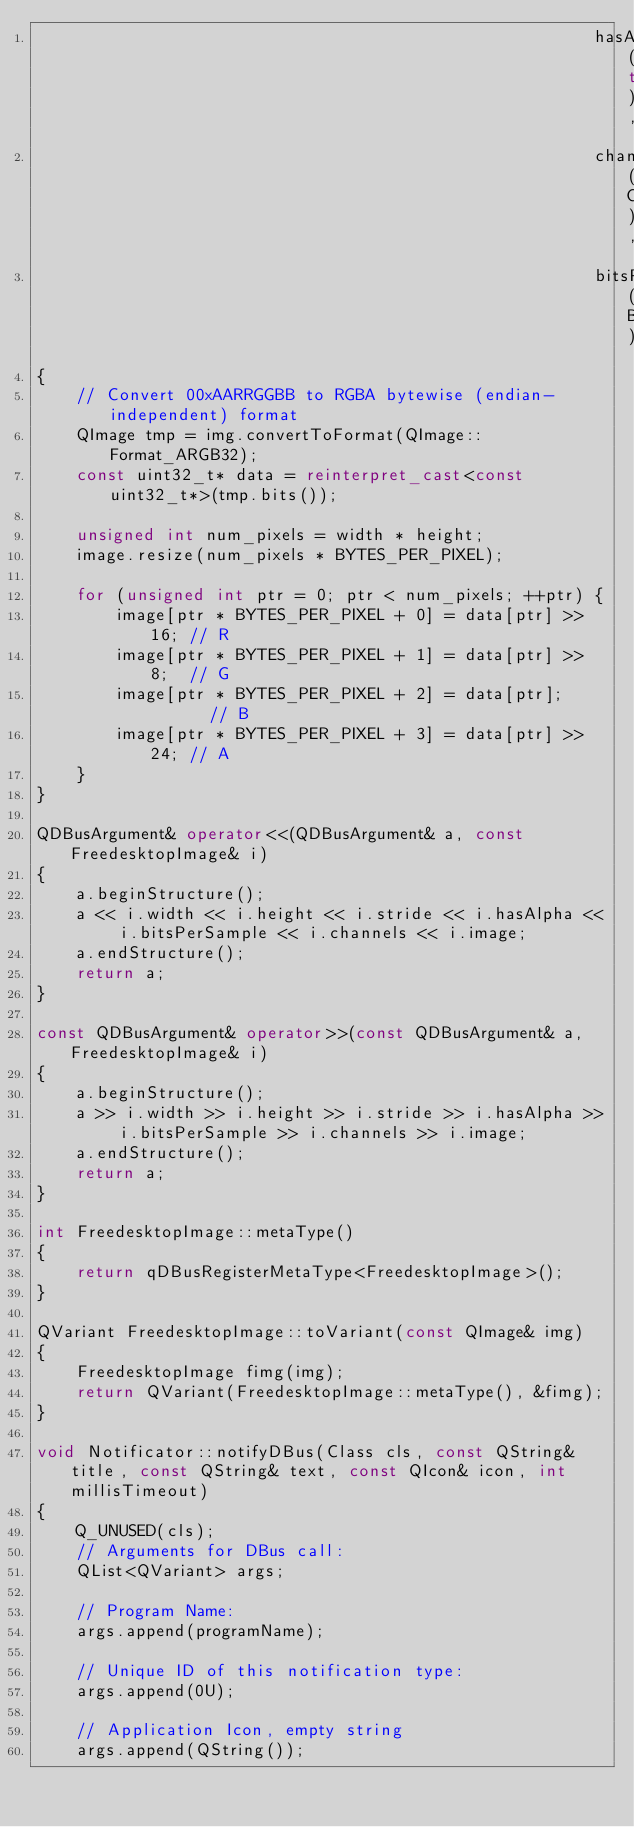<code> <loc_0><loc_0><loc_500><loc_500><_C++_>                                                        hasAlpha(true),
                                                        channels(CHANNELS),
                                                        bitsPerSample(BITS_PER_SAMPLE)
{
    // Convert 00xAARRGGBB to RGBA bytewise (endian-independent) format
    QImage tmp = img.convertToFormat(QImage::Format_ARGB32);
    const uint32_t* data = reinterpret_cast<const uint32_t*>(tmp.bits());

    unsigned int num_pixels = width * height;
    image.resize(num_pixels * BYTES_PER_PIXEL);

    for (unsigned int ptr = 0; ptr < num_pixels; ++ptr) {
        image[ptr * BYTES_PER_PIXEL + 0] = data[ptr] >> 16; // R
        image[ptr * BYTES_PER_PIXEL + 1] = data[ptr] >> 8;  // G
        image[ptr * BYTES_PER_PIXEL + 2] = data[ptr];       // B
        image[ptr * BYTES_PER_PIXEL + 3] = data[ptr] >> 24; // A
    }
}

QDBusArgument& operator<<(QDBusArgument& a, const FreedesktopImage& i)
{
    a.beginStructure();
    a << i.width << i.height << i.stride << i.hasAlpha << i.bitsPerSample << i.channels << i.image;
    a.endStructure();
    return a;
}

const QDBusArgument& operator>>(const QDBusArgument& a, FreedesktopImage& i)
{
    a.beginStructure();
    a >> i.width >> i.height >> i.stride >> i.hasAlpha >> i.bitsPerSample >> i.channels >> i.image;
    a.endStructure();
    return a;
}

int FreedesktopImage::metaType()
{
    return qDBusRegisterMetaType<FreedesktopImage>();
}

QVariant FreedesktopImage::toVariant(const QImage& img)
{
    FreedesktopImage fimg(img);
    return QVariant(FreedesktopImage::metaType(), &fimg);
}

void Notificator::notifyDBus(Class cls, const QString& title, const QString& text, const QIcon& icon, int millisTimeout)
{
    Q_UNUSED(cls);
    // Arguments for DBus call:
    QList<QVariant> args;

    // Program Name:
    args.append(programName);

    // Unique ID of this notification type:
    args.append(0U);

    // Application Icon, empty string
    args.append(QString());
</code> 